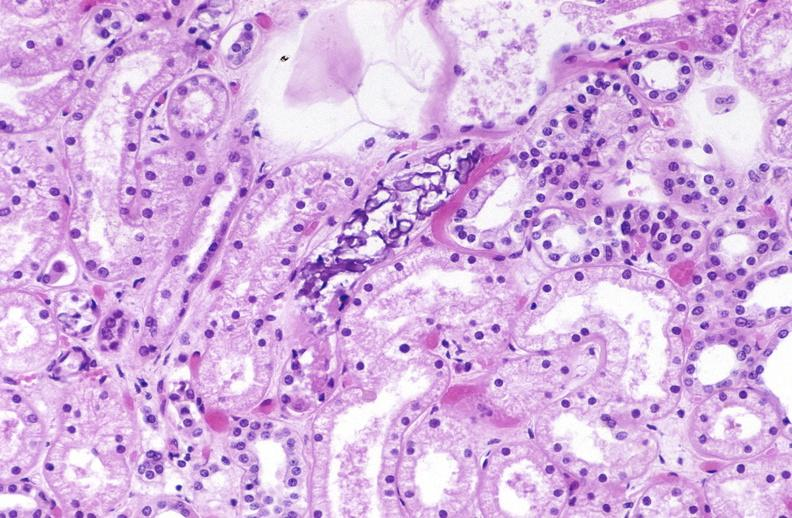s candida in peripheral blood present?
Answer the question using a single word or phrase. No 